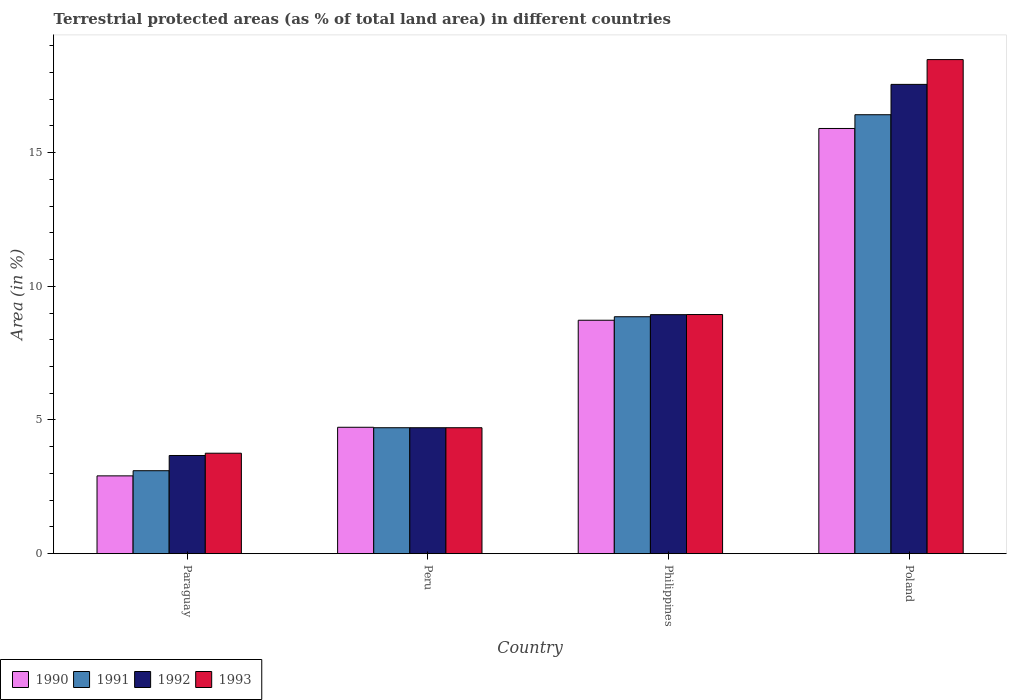Are the number of bars per tick equal to the number of legend labels?
Your answer should be very brief. Yes. How many bars are there on the 2nd tick from the left?
Provide a succinct answer. 4. What is the label of the 3rd group of bars from the left?
Give a very brief answer. Philippines. In how many cases, is the number of bars for a given country not equal to the number of legend labels?
Provide a succinct answer. 0. What is the percentage of terrestrial protected land in 1991 in Poland?
Your answer should be very brief. 16.42. Across all countries, what is the maximum percentage of terrestrial protected land in 1993?
Give a very brief answer. 18.48. Across all countries, what is the minimum percentage of terrestrial protected land in 1990?
Ensure brevity in your answer.  2.91. In which country was the percentage of terrestrial protected land in 1992 maximum?
Provide a succinct answer. Poland. In which country was the percentage of terrestrial protected land in 1992 minimum?
Your answer should be very brief. Paraguay. What is the total percentage of terrestrial protected land in 1992 in the graph?
Offer a very short reply. 34.88. What is the difference between the percentage of terrestrial protected land in 1992 in Paraguay and that in Poland?
Provide a short and direct response. -13.88. What is the difference between the percentage of terrestrial protected land in 1991 in Peru and the percentage of terrestrial protected land in 1990 in Poland?
Give a very brief answer. -11.19. What is the average percentage of terrestrial protected land in 1990 per country?
Offer a very short reply. 8.07. What is the ratio of the percentage of terrestrial protected land in 1993 in Paraguay to that in Poland?
Keep it short and to the point. 0.2. Is the percentage of terrestrial protected land in 1991 in Paraguay less than that in Peru?
Give a very brief answer. Yes. Is the difference between the percentage of terrestrial protected land in 1993 in Paraguay and Poland greater than the difference between the percentage of terrestrial protected land in 1992 in Paraguay and Poland?
Your response must be concise. No. What is the difference between the highest and the second highest percentage of terrestrial protected land in 1990?
Your answer should be compact. 4. What is the difference between the highest and the lowest percentage of terrestrial protected land in 1992?
Provide a succinct answer. 13.88. Is the sum of the percentage of terrestrial protected land in 1992 in Paraguay and Peru greater than the maximum percentage of terrestrial protected land in 1993 across all countries?
Give a very brief answer. No. Is it the case that in every country, the sum of the percentage of terrestrial protected land in 1992 and percentage of terrestrial protected land in 1993 is greater than the percentage of terrestrial protected land in 1991?
Your answer should be very brief. Yes. Are all the bars in the graph horizontal?
Keep it short and to the point. No. How many countries are there in the graph?
Your response must be concise. 4. Are the values on the major ticks of Y-axis written in scientific E-notation?
Ensure brevity in your answer.  No. Does the graph contain grids?
Make the answer very short. No. Where does the legend appear in the graph?
Offer a terse response. Bottom left. How many legend labels are there?
Offer a very short reply. 4. How are the legend labels stacked?
Offer a terse response. Horizontal. What is the title of the graph?
Give a very brief answer. Terrestrial protected areas (as % of total land area) in different countries. Does "2001" appear as one of the legend labels in the graph?
Give a very brief answer. No. What is the label or title of the Y-axis?
Provide a succinct answer. Area (in %). What is the Area (in %) in 1990 in Paraguay?
Keep it short and to the point. 2.91. What is the Area (in %) in 1991 in Paraguay?
Ensure brevity in your answer.  3.1. What is the Area (in %) of 1992 in Paraguay?
Your answer should be very brief. 3.67. What is the Area (in %) in 1993 in Paraguay?
Provide a succinct answer. 3.76. What is the Area (in %) in 1990 in Peru?
Provide a short and direct response. 4.73. What is the Area (in %) in 1991 in Peru?
Offer a terse response. 4.71. What is the Area (in %) of 1992 in Peru?
Offer a very short reply. 4.71. What is the Area (in %) of 1993 in Peru?
Give a very brief answer. 4.71. What is the Area (in %) of 1990 in Philippines?
Offer a terse response. 8.73. What is the Area (in %) of 1991 in Philippines?
Offer a very short reply. 8.86. What is the Area (in %) of 1992 in Philippines?
Provide a short and direct response. 8.94. What is the Area (in %) of 1993 in Philippines?
Provide a short and direct response. 8.94. What is the Area (in %) in 1990 in Poland?
Ensure brevity in your answer.  15.9. What is the Area (in %) of 1991 in Poland?
Make the answer very short. 16.42. What is the Area (in %) of 1992 in Poland?
Ensure brevity in your answer.  17.55. What is the Area (in %) of 1993 in Poland?
Your response must be concise. 18.48. Across all countries, what is the maximum Area (in %) of 1990?
Offer a very short reply. 15.9. Across all countries, what is the maximum Area (in %) of 1991?
Ensure brevity in your answer.  16.42. Across all countries, what is the maximum Area (in %) in 1992?
Give a very brief answer. 17.55. Across all countries, what is the maximum Area (in %) of 1993?
Make the answer very short. 18.48. Across all countries, what is the minimum Area (in %) in 1990?
Make the answer very short. 2.91. Across all countries, what is the minimum Area (in %) in 1991?
Offer a very short reply. 3.1. Across all countries, what is the minimum Area (in %) of 1992?
Ensure brevity in your answer.  3.67. Across all countries, what is the minimum Area (in %) of 1993?
Keep it short and to the point. 3.76. What is the total Area (in %) of 1990 in the graph?
Give a very brief answer. 32.27. What is the total Area (in %) in 1991 in the graph?
Offer a very short reply. 33.09. What is the total Area (in %) of 1992 in the graph?
Offer a terse response. 34.88. What is the total Area (in %) of 1993 in the graph?
Your answer should be very brief. 35.89. What is the difference between the Area (in %) of 1990 in Paraguay and that in Peru?
Your answer should be compact. -1.82. What is the difference between the Area (in %) in 1991 in Paraguay and that in Peru?
Your answer should be very brief. -1.61. What is the difference between the Area (in %) of 1992 in Paraguay and that in Peru?
Provide a succinct answer. -1.04. What is the difference between the Area (in %) of 1993 in Paraguay and that in Peru?
Give a very brief answer. -0.95. What is the difference between the Area (in %) of 1990 in Paraguay and that in Philippines?
Your response must be concise. -5.82. What is the difference between the Area (in %) of 1991 in Paraguay and that in Philippines?
Make the answer very short. -5.76. What is the difference between the Area (in %) of 1992 in Paraguay and that in Philippines?
Your answer should be compact. -5.27. What is the difference between the Area (in %) of 1993 in Paraguay and that in Philippines?
Your response must be concise. -5.19. What is the difference between the Area (in %) of 1990 in Paraguay and that in Poland?
Keep it short and to the point. -12.99. What is the difference between the Area (in %) in 1991 in Paraguay and that in Poland?
Your answer should be compact. -13.32. What is the difference between the Area (in %) of 1992 in Paraguay and that in Poland?
Your answer should be very brief. -13.88. What is the difference between the Area (in %) of 1993 in Paraguay and that in Poland?
Your response must be concise. -14.72. What is the difference between the Area (in %) of 1990 in Peru and that in Philippines?
Keep it short and to the point. -4. What is the difference between the Area (in %) in 1991 in Peru and that in Philippines?
Offer a terse response. -4.15. What is the difference between the Area (in %) of 1992 in Peru and that in Philippines?
Provide a short and direct response. -4.23. What is the difference between the Area (in %) of 1993 in Peru and that in Philippines?
Make the answer very short. -4.23. What is the difference between the Area (in %) in 1990 in Peru and that in Poland?
Offer a terse response. -11.18. What is the difference between the Area (in %) of 1991 in Peru and that in Poland?
Provide a short and direct response. -11.71. What is the difference between the Area (in %) in 1992 in Peru and that in Poland?
Offer a terse response. -12.84. What is the difference between the Area (in %) of 1993 in Peru and that in Poland?
Your answer should be compact. -13.77. What is the difference between the Area (in %) of 1990 in Philippines and that in Poland?
Your answer should be very brief. -7.17. What is the difference between the Area (in %) of 1991 in Philippines and that in Poland?
Provide a succinct answer. -7.56. What is the difference between the Area (in %) in 1992 in Philippines and that in Poland?
Make the answer very short. -8.61. What is the difference between the Area (in %) of 1993 in Philippines and that in Poland?
Your response must be concise. -9.54. What is the difference between the Area (in %) of 1990 in Paraguay and the Area (in %) of 1991 in Peru?
Provide a short and direct response. -1.8. What is the difference between the Area (in %) of 1990 in Paraguay and the Area (in %) of 1992 in Peru?
Keep it short and to the point. -1.8. What is the difference between the Area (in %) of 1990 in Paraguay and the Area (in %) of 1993 in Peru?
Offer a very short reply. -1.8. What is the difference between the Area (in %) of 1991 in Paraguay and the Area (in %) of 1992 in Peru?
Ensure brevity in your answer.  -1.61. What is the difference between the Area (in %) of 1991 in Paraguay and the Area (in %) of 1993 in Peru?
Offer a very short reply. -1.61. What is the difference between the Area (in %) of 1992 in Paraguay and the Area (in %) of 1993 in Peru?
Provide a succinct answer. -1.04. What is the difference between the Area (in %) in 1990 in Paraguay and the Area (in %) in 1991 in Philippines?
Provide a succinct answer. -5.95. What is the difference between the Area (in %) of 1990 in Paraguay and the Area (in %) of 1992 in Philippines?
Provide a succinct answer. -6.03. What is the difference between the Area (in %) in 1990 in Paraguay and the Area (in %) in 1993 in Philippines?
Your answer should be very brief. -6.03. What is the difference between the Area (in %) in 1991 in Paraguay and the Area (in %) in 1992 in Philippines?
Your response must be concise. -5.84. What is the difference between the Area (in %) of 1991 in Paraguay and the Area (in %) of 1993 in Philippines?
Your response must be concise. -5.84. What is the difference between the Area (in %) of 1992 in Paraguay and the Area (in %) of 1993 in Philippines?
Make the answer very short. -5.27. What is the difference between the Area (in %) in 1990 in Paraguay and the Area (in %) in 1991 in Poland?
Provide a short and direct response. -13.51. What is the difference between the Area (in %) in 1990 in Paraguay and the Area (in %) in 1992 in Poland?
Offer a very short reply. -14.64. What is the difference between the Area (in %) in 1990 in Paraguay and the Area (in %) in 1993 in Poland?
Ensure brevity in your answer.  -15.57. What is the difference between the Area (in %) in 1991 in Paraguay and the Area (in %) in 1992 in Poland?
Your answer should be very brief. -14.45. What is the difference between the Area (in %) in 1991 in Paraguay and the Area (in %) in 1993 in Poland?
Provide a short and direct response. -15.38. What is the difference between the Area (in %) of 1992 in Paraguay and the Area (in %) of 1993 in Poland?
Ensure brevity in your answer.  -14.81. What is the difference between the Area (in %) of 1990 in Peru and the Area (in %) of 1991 in Philippines?
Make the answer very short. -4.13. What is the difference between the Area (in %) of 1990 in Peru and the Area (in %) of 1992 in Philippines?
Make the answer very short. -4.21. What is the difference between the Area (in %) of 1990 in Peru and the Area (in %) of 1993 in Philippines?
Provide a succinct answer. -4.22. What is the difference between the Area (in %) in 1991 in Peru and the Area (in %) in 1992 in Philippines?
Keep it short and to the point. -4.23. What is the difference between the Area (in %) in 1991 in Peru and the Area (in %) in 1993 in Philippines?
Ensure brevity in your answer.  -4.23. What is the difference between the Area (in %) of 1992 in Peru and the Area (in %) of 1993 in Philippines?
Provide a short and direct response. -4.23. What is the difference between the Area (in %) of 1990 in Peru and the Area (in %) of 1991 in Poland?
Your answer should be very brief. -11.69. What is the difference between the Area (in %) in 1990 in Peru and the Area (in %) in 1992 in Poland?
Provide a short and direct response. -12.83. What is the difference between the Area (in %) of 1990 in Peru and the Area (in %) of 1993 in Poland?
Provide a succinct answer. -13.75. What is the difference between the Area (in %) of 1991 in Peru and the Area (in %) of 1992 in Poland?
Provide a succinct answer. -12.84. What is the difference between the Area (in %) of 1991 in Peru and the Area (in %) of 1993 in Poland?
Provide a short and direct response. -13.77. What is the difference between the Area (in %) of 1992 in Peru and the Area (in %) of 1993 in Poland?
Give a very brief answer. -13.77. What is the difference between the Area (in %) of 1990 in Philippines and the Area (in %) of 1991 in Poland?
Make the answer very short. -7.69. What is the difference between the Area (in %) in 1990 in Philippines and the Area (in %) in 1992 in Poland?
Your response must be concise. -8.82. What is the difference between the Area (in %) in 1990 in Philippines and the Area (in %) in 1993 in Poland?
Make the answer very short. -9.75. What is the difference between the Area (in %) of 1991 in Philippines and the Area (in %) of 1992 in Poland?
Your answer should be compact. -8.69. What is the difference between the Area (in %) of 1991 in Philippines and the Area (in %) of 1993 in Poland?
Your answer should be compact. -9.62. What is the difference between the Area (in %) in 1992 in Philippines and the Area (in %) in 1993 in Poland?
Your answer should be very brief. -9.54. What is the average Area (in %) in 1990 per country?
Your response must be concise. 8.07. What is the average Area (in %) of 1991 per country?
Offer a terse response. 8.27. What is the average Area (in %) of 1992 per country?
Offer a very short reply. 8.72. What is the average Area (in %) in 1993 per country?
Give a very brief answer. 8.97. What is the difference between the Area (in %) in 1990 and Area (in %) in 1991 in Paraguay?
Make the answer very short. -0.19. What is the difference between the Area (in %) of 1990 and Area (in %) of 1992 in Paraguay?
Keep it short and to the point. -0.76. What is the difference between the Area (in %) in 1990 and Area (in %) in 1993 in Paraguay?
Provide a succinct answer. -0.85. What is the difference between the Area (in %) of 1991 and Area (in %) of 1992 in Paraguay?
Give a very brief answer. -0.57. What is the difference between the Area (in %) in 1991 and Area (in %) in 1993 in Paraguay?
Provide a short and direct response. -0.65. What is the difference between the Area (in %) of 1992 and Area (in %) of 1993 in Paraguay?
Your response must be concise. -0.09. What is the difference between the Area (in %) of 1990 and Area (in %) of 1991 in Peru?
Offer a very short reply. 0.02. What is the difference between the Area (in %) of 1990 and Area (in %) of 1992 in Peru?
Give a very brief answer. 0.02. What is the difference between the Area (in %) of 1990 and Area (in %) of 1993 in Peru?
Keep it short and to the point. 0.02. What is the difference between the Area (in %) in 1991 and Area (in %) in 1992 in Peru?
Your response must be concise. 0. What is the difference between the Area (in %) of 1991 and Area (in %) of 1993 in Peru?
Keep it short and to the point. 0. What is the difference between the Area (in %) of 1992 and Area (in %) of 1993 in Peru?
Your answer should be compact. 0. What is the difference between the Area (in %) of 1990 and Area (in %) of 1991 in Philippines?
Offer a very short reply. -0.13. What is the difference between the Area (in %) of 1990 and Area (in %) of 1992 in Philippines?
Your answer should be compact. -0.21. What is the difference between the Area (in %) of 1990 and Area (in %) of 1993 in Philippines?
Give a very brief answer. -0.21. What is the difference between the Area (in %) in 1991 and Area (in %) in 1992 in Philippines?
Keep it short and to the point. -0.08. What is the difference between the Area (in %) of 1991 and Area (in %) of 1993 in Philippines?
Provide a succinct answer. -0.08. What is the difference between the Area (in %) in 1992 and Area (in %) in 1993 in Philippines?
Offer a terse response. -0. What is the difference between the Area (in %) of 1990 and Area (in %) of 1991 in Poland?
Make the answer very short. -0.51. What is the difference between the Area (in %) of 1990 and Area (in %) of 1992 in Poland?
Offer a very short reply. -1.65. What is the difference between the Area (in %) in 1990 and Area (in %) in 1993 in Poland?
Keep it short and to the point. -2.58. What is the difference between the Area (in %) in 1991 and Area (in %) in 1992 in Poland?
Keep it short and to the point. -1.13. What is the difference between the Area (in %) of 1991 and Area (in %) of 1993 in Poland?
Your response must be concise. -2.06. What is the difference between the Area (in %) in 1992 and Area (in %) in 1993 in Poland?
Provide a short and direct response. -0.93. What is the ratio of the Area (in %) in 1990 in Paraguay to that in Peru?
Keep it short and to the point. 0.62. What is the ratio of the Area (in %) of 1991 in Paraguay to that in Peru?
Make the answer very short. 0.66. What is the ratio of the Area (in %) in 1992 in Paraguay to that in Peru?
Make the answer very short. 0.78. What is the ratio of the Area (in %) in 1993 in Paraguay to that in Peru?
Provide a succinct answer. 0.8. What is the ratio of the Area (in %) of 1991 in Paraguay to that in Philippines?
Ensure brevity in your answer.  0.35. What is the ratio of the Area (in %) in 1992 in Paraguay to that in Philippines?
Ensure brevity in your answer.  0.41. What is the ratio of the Area (in %) of 1993 in Paraguay to that in Philippines?
Ensure brevity in your answer.  0.42. What is the ratio of the Area (in %) in 1990 in Paraguay to that in Poland?
Your answer should be very brief. 0.18. What is the ratio of the Area (in %) in 1991 in Paraguay to that in Poland?
Ensure brevity in your answer.  0.19. What is the ratio of the Area (in %) in 1992 in Paraguay to that in Poland?
Offer a terse response. 0.21. What is the ratio of the Area (in %) of 1993 in Paraguay to that in Poland?
Offer a terse response. 0.2. What is the ratio of the Area (in %) of 1990 in Peru to that in Philippines?
Your answer should be very brief. 0.54. What is the ratio of the Area (in %) in 1991 in Peru to that in Philippines?
Give a very brief answer. 0.53. What is the ratio of the Area (in %) of 1992 in Peru to that in Philippines?
Offer a terse response. 0.53. What is the ratio of the Area (in %) of 1993 in Peru to that in Philippines?
Your answer should be very brief. 0.53. What is the ratio of the Area (in %) in 1990 in Peru to that in Poland?
Provide a succinct answer. 0.3. What is the ratio of the Area (in %) in 1991 in Peru to that in Poland?
Ensure brevity in your answer.  0.29. What is the ratio of the Area (in %) of 1992 in Peru to that in Poland?
Offer a very short reply. 0.27. What is the ratio of the Area (in %) of 1993 in Peru to that in Poland?
Offer a very short reply. 0.25. What is the ratio of the Area (in %) of 1990 in Philippines to that in Poland?
Ensure brevity in your answer.  0.55. What is the ratio of the Area (in %) of 1991 in Philippines to that in Poland?
Your answer should be compact. 0.54. What is the ratio of the Area (in %) in 1992 in Philippines to that in Poland?
Ensure brevity in your answer.  0.51. What is the ratio of the Area (in %) in 1993 in Philippines to that in Poland?
Provide a succinct answer. 0.48. What is the difference between the highest and the second highest Area (in %) of 1990?
Offer a very short reply. 7.17. What is the difference between the highest and the second highest Area (in %) in 1991?
Make the answer very short. 7.56. What is the difference between the highest and the second highest Area (in %) in 1992?
Provide a short and direct response. 8.61. What is the difference between the highest and the second highest Area (in %) of 1993?
Offer a terse response. 9.54. What is the difference between the highest and the lowest Area (in %) of 1990?
Provide a short and direct response. 12.99. What is the difference between the highest and the lowest Area (in %) of 1991?
Your response must be concise. 13.32. What is the difference between the highest and the lowest Area (in %) in 1992?
Provide a short and direct response. 13.88. What is the difference between the highest and the lowest Area (in %) of 1993?
Make the answer very short. 14.72. 